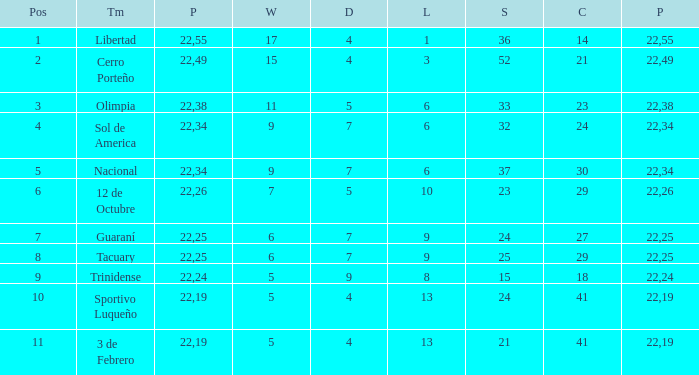Could you help me parse every detail presented in this table? {'header': ['Pos', 'Tm', 'P', 'W', 'D', 'L', 'S', 'C', 'P'], 'rows': [['1', 'Libertad', '22', '17', '4', '1', '36', '14', '55'], ['2', 'Cerro Porteño', '22', '15', '4', '3', '52', '21', '49'], ['3', 'Olimpia', '22', '11', '5', '6', '33', '23', '38'], ['4', 'Sol de America', '22', '9', '7', '6', '32', '24', '34'], ['5', 'Nacional', '22', '9', '7', '6', '37', '30', '34'], ['6', '12 de Octubre', '22', '7', '5', '10', '23', '29', '26'], ['7', 'Guaraní', '22', '6', '7', '9', '24', '27', '25'], ['8', 'Tacuary', '22', '6', '7', '9', '25', '29', '25'], ['9', 'Trinidense', '22', '5', '9', '8', '15', '18', '24'], ['10', 'Sportivo Luqueño', '22', '5', '4', '13', '24', '41', '19'], ['11', '3 de Febrero', '22', '5', '4', '13', '21', '41', '19']]} What is the value scored when there were 19 points for the team 3 de Febrero? 21.0. 